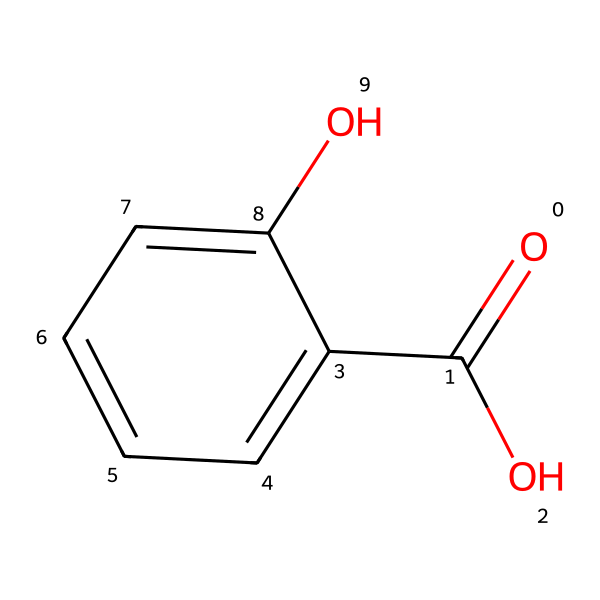What is the molecular formula of salicylic acid? The molecular formula can be derived from the structure; there are 7 carbon atoms, 6 hydrogen atoms, and 3 oxygen atoms, resulting in C7H6O3.
Answer: C7H6O3 How many hydroxyl groups are present in salicylic acid? The structure contains one hydroxyl (-OH) group, which is indicated by the -OH attached to the benzene ring.
Answer: one What is the role of salicylic acid in acne treatment? Salicylic acid acts as a beta hydroxy acid (BHA) that helps exfoliate the skin, unclog pores, and reduce inflammation, making it effective for acne treatment.
Answer: exfoliant How many rings are present in the molecular structure of salicylic acid? The structure contains one aromatic ring (the benzene ring), which is evident from the hexagon shape with alternating double bonds.
Answer: one What type of acid is salicylic acid? Salicylic acid is a carboxylic acid due to the presence of the carboxyl functional group (-COOH) shown in the structure.
Answer: carboxylic acid Which functional groups are identified in salicylic acid? The chemical structure shows two functional groups: the hydroxyl (-OH) group and the carboxyl (-COOH) group, which are responsible for its properties.
Answer: hydroxyl and carboxyl What effect does the molecular structure of salicylic acid have on its solubility in water? The presence of hydroxyl and carboxyl groups contributes to the polar nature of salicylic acid, enhancing its solubility in water.
Answer: increases solubility 